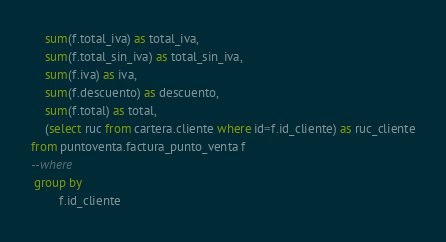Convert code to text. <code><loc_0><loc_0><loc_500><loc_500><_SQL_>	sum(f.total_iva) as total_iva,
	sum(f.total_sin_iva) as total_sin_iva,
	sum(f.iva) as iva,
	sum(f.descuento) as descuento,
	sum(f.total) as total,
	(select ruc from cartera.cliente where id=f.id_cliente) as ruc_cliente
from puntoventa.factura_punto_venta f
--where
 group by 
		f.id_cliente</code> 